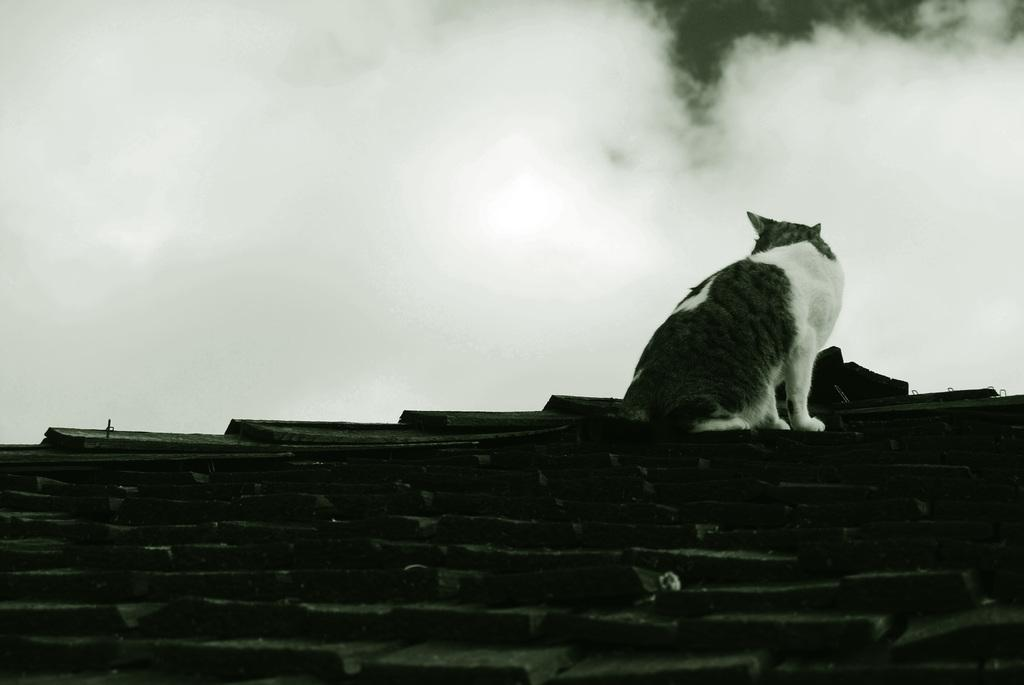What is the main subject in the center of the image? There is a cat in the center of the image. What is located at the bottom of the image? There is a wall at the bottom of the image. What can be seen at the top of the image? The sky is visible at the top of the image. What page is the cat reading in the image? There is no page or book present in the image, so the cat cannot be reading anything. 